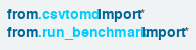Convert code to text. <code><loc_0><loc_0><loc_500><loc_500><_Python_>from .csvtomd import *
from .run_benchmark import *</code> 